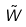<formula> <loc_0><loc_0><loc_500><loc_500>\tilde { W }</formula> 